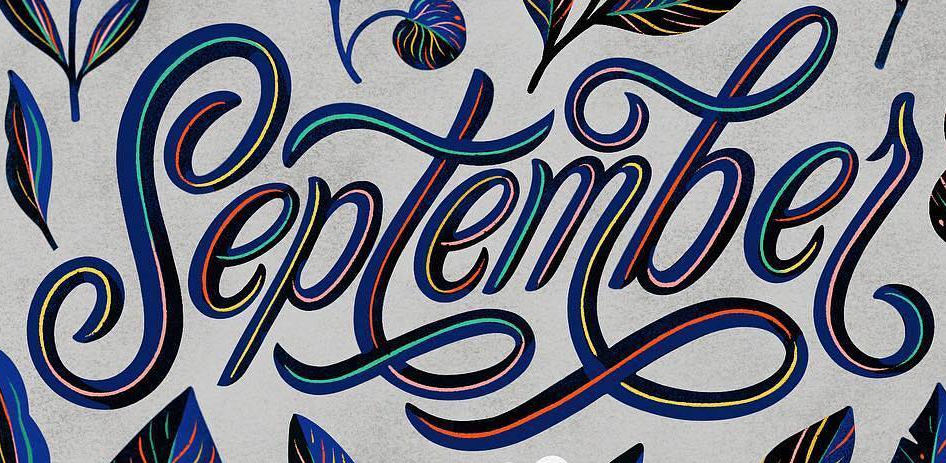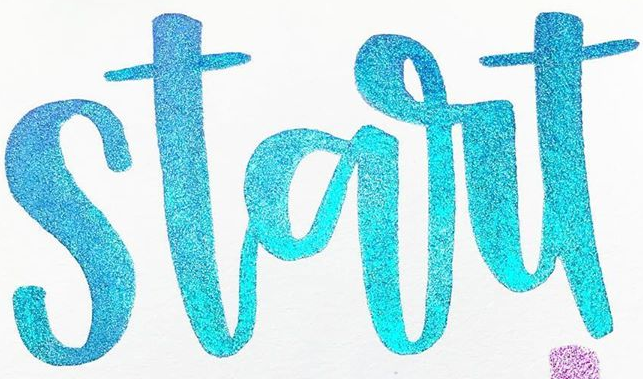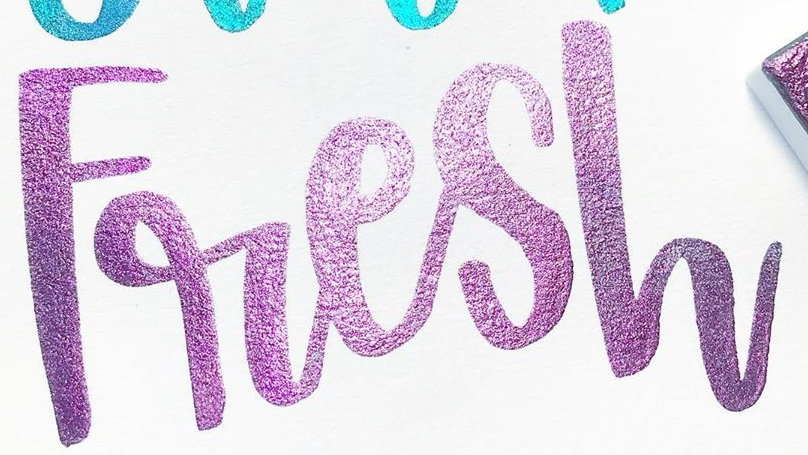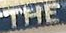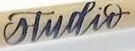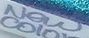What text is displayed in these images sequentially, separated by a semicolon? septembel; start; Fresh; THE; studir; New 